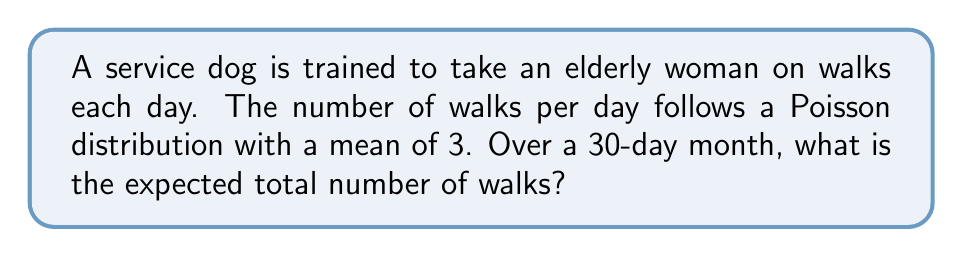Could you help me with this problem? Let's approach this step-by-step:

1) Let $X$ be the random variable representing the number of walks per day. We're told that $X$ follows a Poisson distribution with mean $\lambda = 3$.

2) The expected value of a Poisson distribution is equal to its parameter $\lambda$. So, $E[X] = 3$ walks per day.

3) Let $Y$ be the random variable representing the total number of walks over 30 days. We can express $Y$ as the sum of 30 independent, identically distributed Poisson random variables:

   $Y = X_1 + X_2 + ... + X_{30}$

   where each $X_i$ represents the number of walks on day $i$.

4) A key property of expected values is linearity:

   $E[aX + bY] = aE[X] + bE[Y]$

5) Applying this to our sum of 30 random variables:

   $E[Y] = E[X_1 + X_2 + ... + X_{30}]$
   $= E[X_1] + E[X_2] + ... + E[X_{30}]$

6) Since each $X_i$ has the same distribution with $E[X_i] = 3$:

   $E[Y] = 3 + 3 + ... + 3$ (30 times)
   $= 30 * 3 = 90$

Therefore, the expected total number of walks over a 30-day month is 90.
Answer: 90 walks 